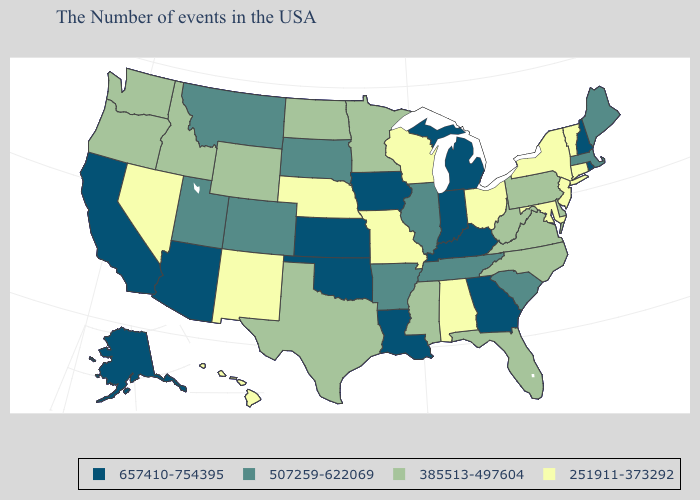What is the lowest value in the USA?
Write a very short answer. 251911-373292. What is the value of Kentucky?
Concise answer only. 657410-754395. Name the states that have a value in the range 507259-622069?
Give a very brief answer. Maine, Massachusetts, South Carolina, Tennessee, Illinois, Arkansas, South Dakota, Colorado, Utah, Montana. What is the value of Kansas?
Quick response, please. 657410-754395. Name the states that have a value in the range 385513-497604?
Write a very short answer. Delaware, Pennsylvania, Virginia, North Carolina, West Virginia, Florida, Mississippi, Minnesota, Texas, North Dakota, Wyoming, Idaho, Washington, Oregon. What is the highest value in the West ?
Keep it brief. 657410-754395. What is the value of West Virginia?
Short answer required. 385513-497604. What is the value of Delaware?
Be succinct. 385513-497604. What is the value of Mississippi?
Quick response, please. 385513-497604. What is the highest value in the South ?
Short answer required. 657410-754395. Among the states that border Georgia , does Alabama have the lowest value?
Quick response, please. Yes. Among the states that border West Virginia , does Kentucky have the highest value?
Concise answer only. Yes. 